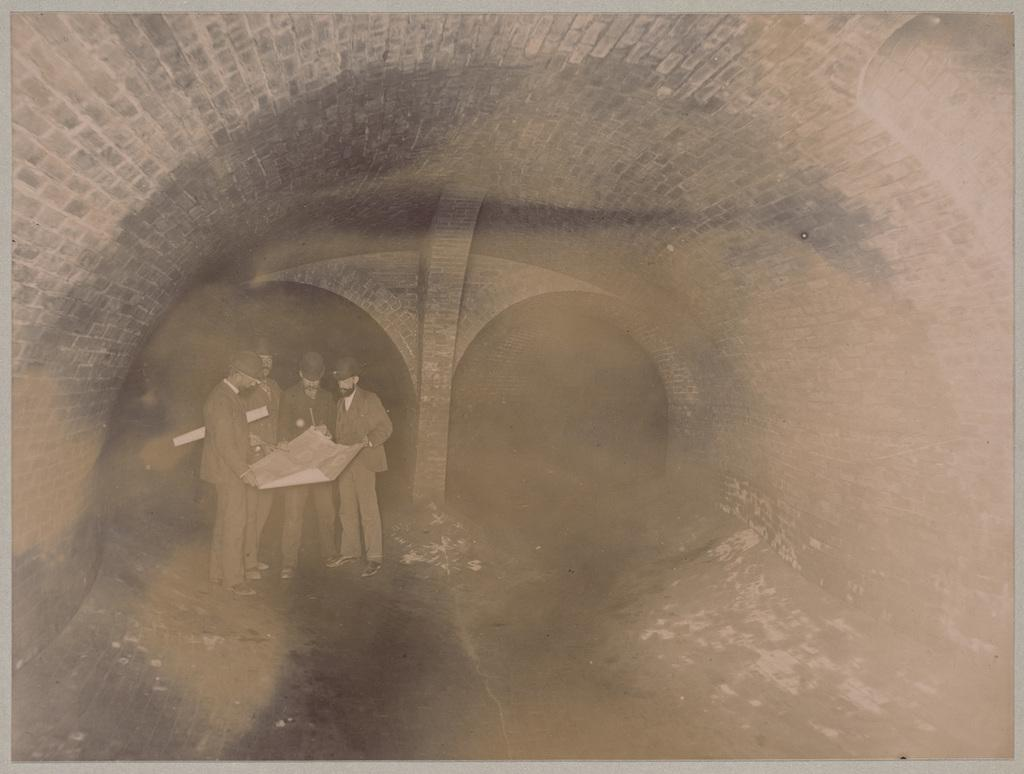What is the main feature of the image? There is a tunnel in the image. What are the people in the image doing? The people are standing on a path and holding a chart. Are there any borders visible in the image? Yes, the image has borders. What type of cup is being used by the father in the image? There is no father or cup present in the image. How many letters are visible on the chart held by the people in the image? The provided facts do not mention the number of letters on the chart, so we cannot definitively answer this question. 